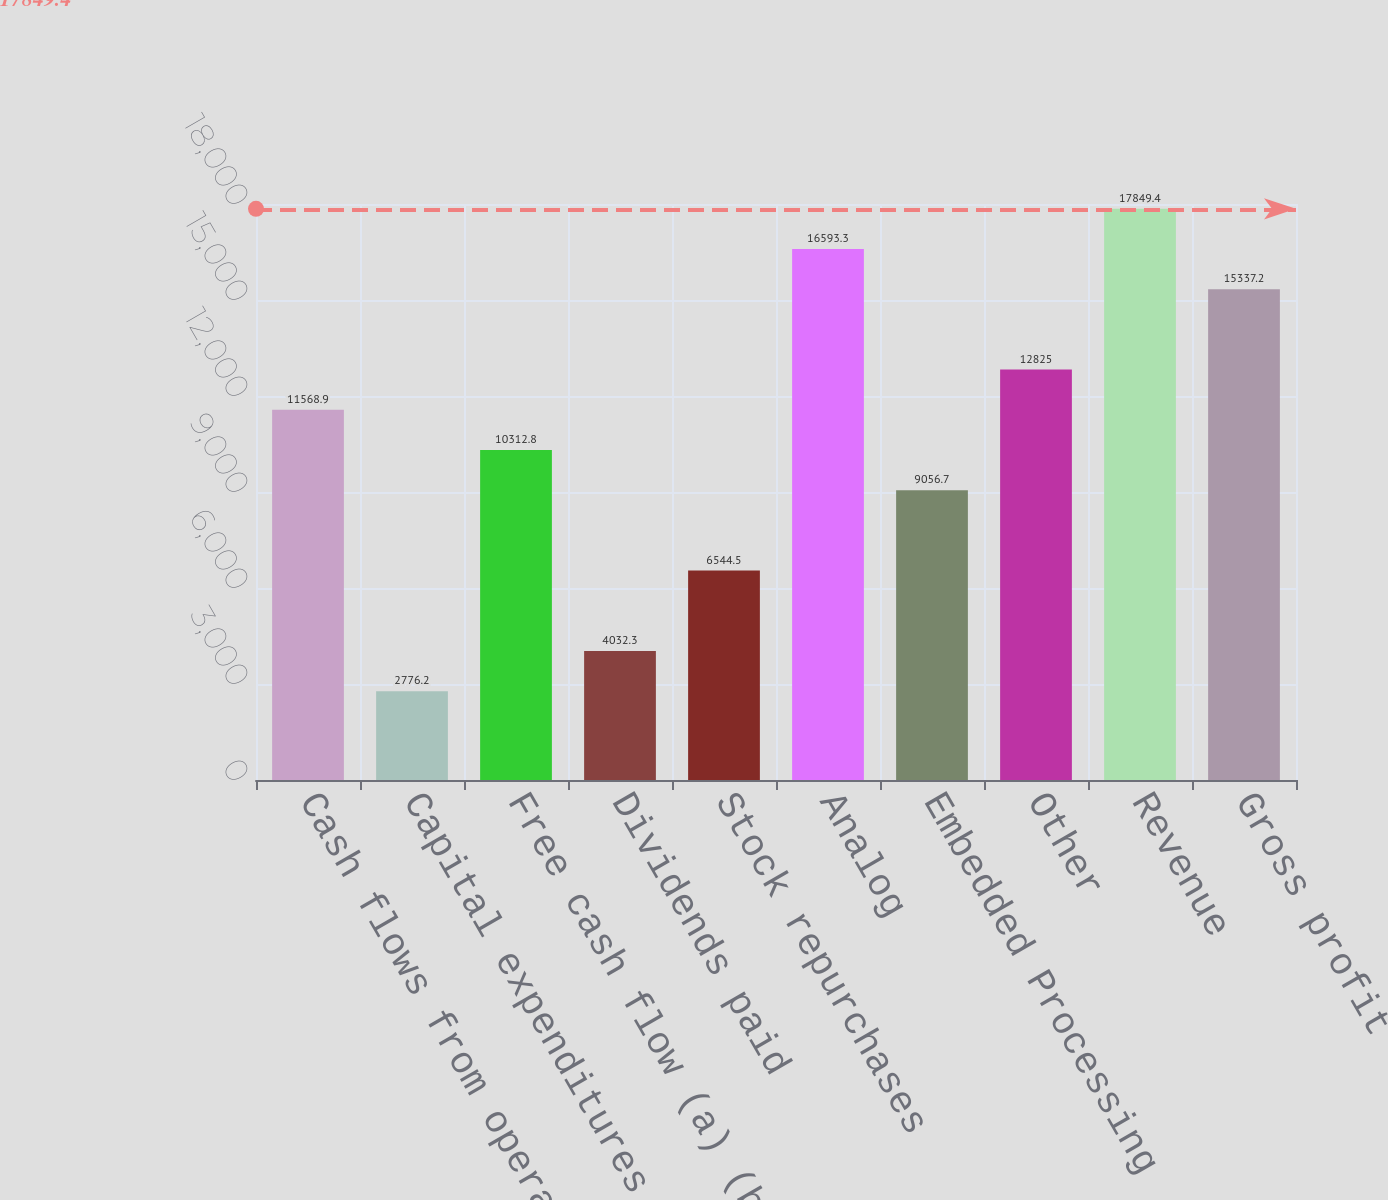Convert chart. <chart><loc_0><loc_0><loc_500><loc_500><bar_chart><fcel>Cash flows from operating<fcel>Capital expenditures<fcel>Free cash flow (a) (b)<fcel>Dividends paid<fcel>Stock repurchases<fcel>Analog<fcel>Embedded Processing<fcel>Other<fcel>Revenue<fcel>Gross profit<nl><fcel>11568.9<fcel>2776.2<fcel>10312.8<fcel>4032.3<fcel>6544.5<fcel>16593.3<fcel>9056.7<fcel>12825<fcel>17849.4<fcel>15337.2<nl></chart> 